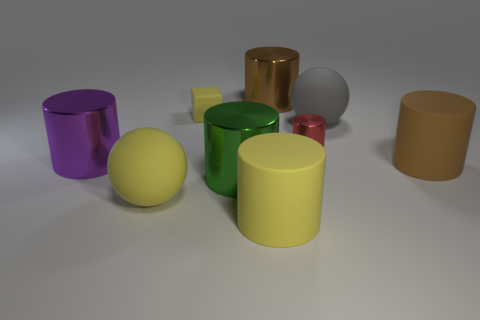How do the objects' colors interact with the light in the image? The objects' colors interact with the light to varying degrees due to their different surfaces. The glossy objects, such as the purple, yellow, and green cylinders, and the red sphere, reflect the light more brightly, highlighting their vibrant colors. The matte-finished objects, like the large brown cylinder and the gray rubber ball, absorb more light, resulting in a softer reflection and more muted colors. 